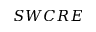<formula> <loc_0><loc_0><loc_500><loc_500>S W C R E</formula> 